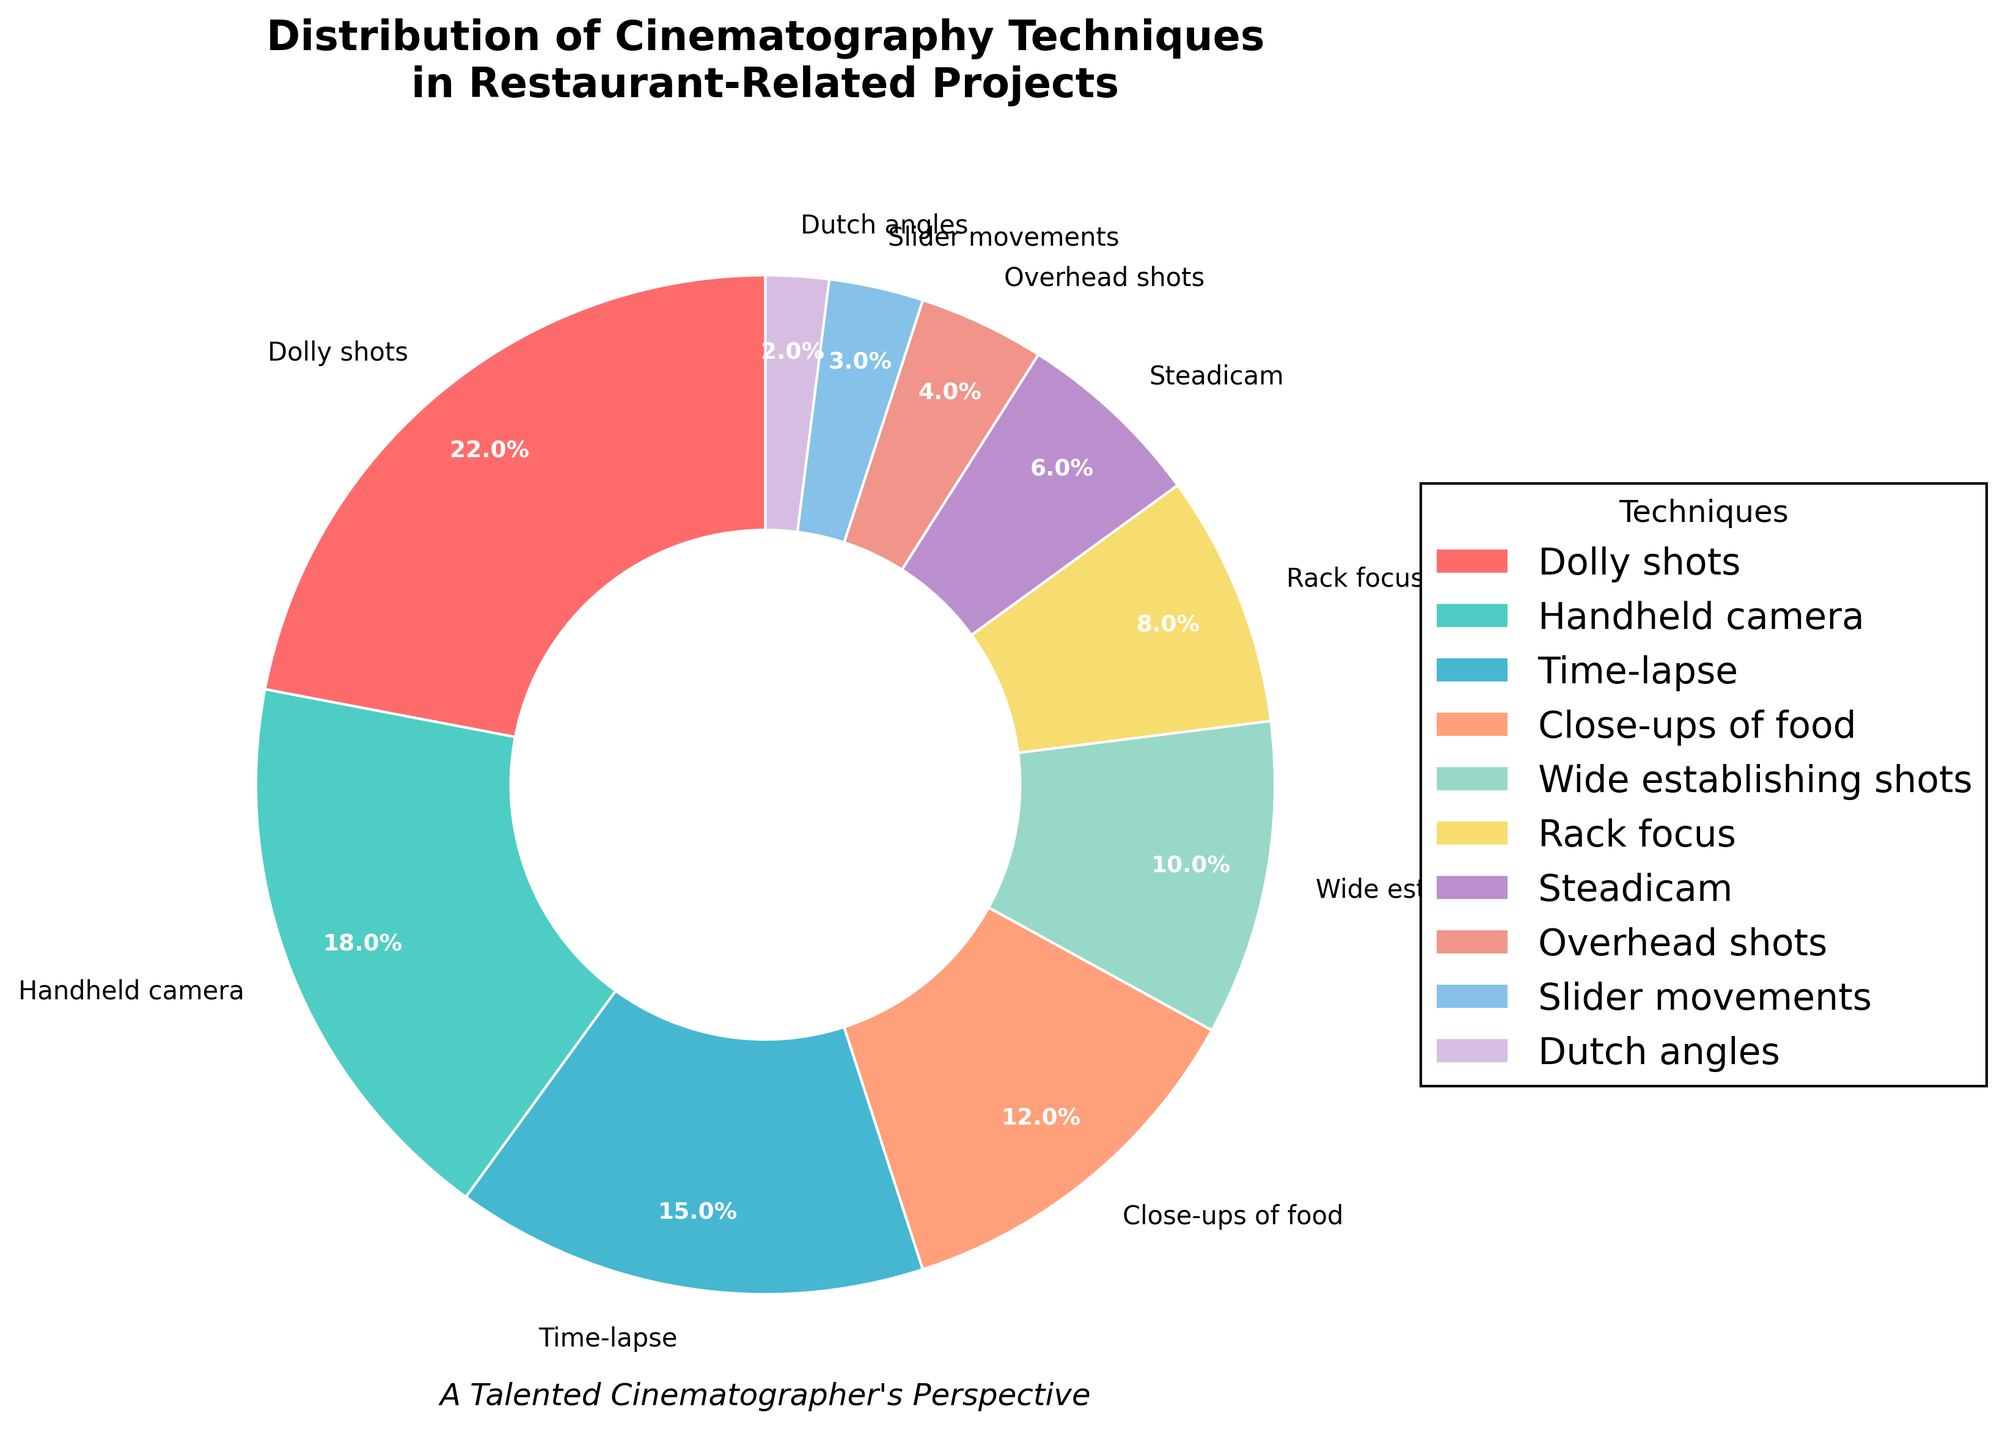Which cinematography technique has the largest share in restaurant-related projects? Look at the slice occupying the largest area in the pie chart, which is labeled "Dolly shots" with 22%.
Answer: Dolly shots Which two techniques combined make up nearly one-third of the total distribution? Add the percentages of the two techniques with the highest values: Dolly shots (22%) + Handheld camera (18%) = 40%, which is more than one-third.
Answer: Dolly shots and Handheld camera Which techniques have a percentage below 5%? Identify the techniques with percentages less than 5%: Overhead shots (4%), Slider movements (3%), and Dutch angles (2%).
Answer: Overhead shots, Slider movements, and Dutch angles Are there more techniques contributing exactly 12% or more than 20% to the distribution? Techniques exactly 12%: Close-ups of food (1 technique); Techniques more than 20%: Dolly shots (22%) (1 technique).
Answer: Equal number Which cinematography technique has the closest percentage to Rack focus? Identify the technique whose percentage is closest to 8% (Rack focus). Close-ups of food has 12%, which is the closest.
Answer: Close-ups of food How many techniques are in the list? Count the number of slices in the pie chart. Each slice represents a technique.
Answer: 10 